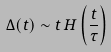<formula> <loc_0><loc_0><loc_500><loc_500>\Delta ( t ) \sim t \, H \left ( \frac { t } { \tau } \right )</formula> 